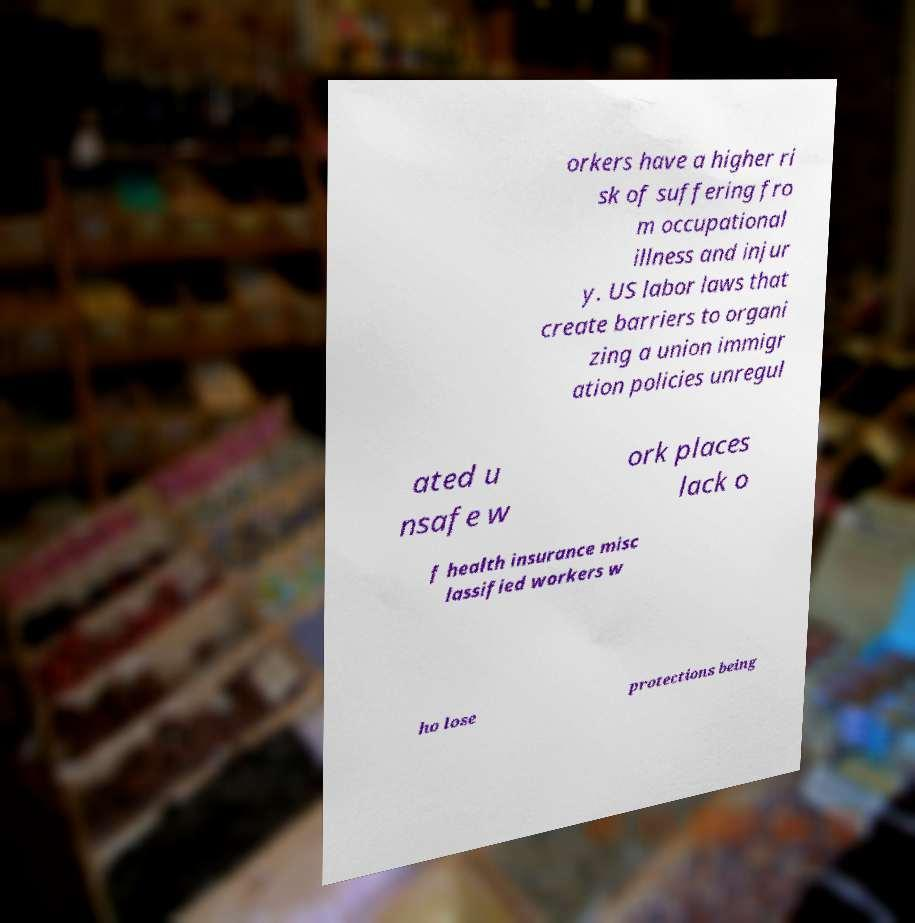Can you read and provide the text displayed in the image?This photo seems to have some interesting text. Can you extract and type it out for me? orkers have a higher ri sk of suffering fro m occupational illness and injur y. US labor laws that create barriers to organi zing a union immigr ation policies unregul ated u nsafe w ork places lack o f health insurance misc lassified workers w ho lose protections being 